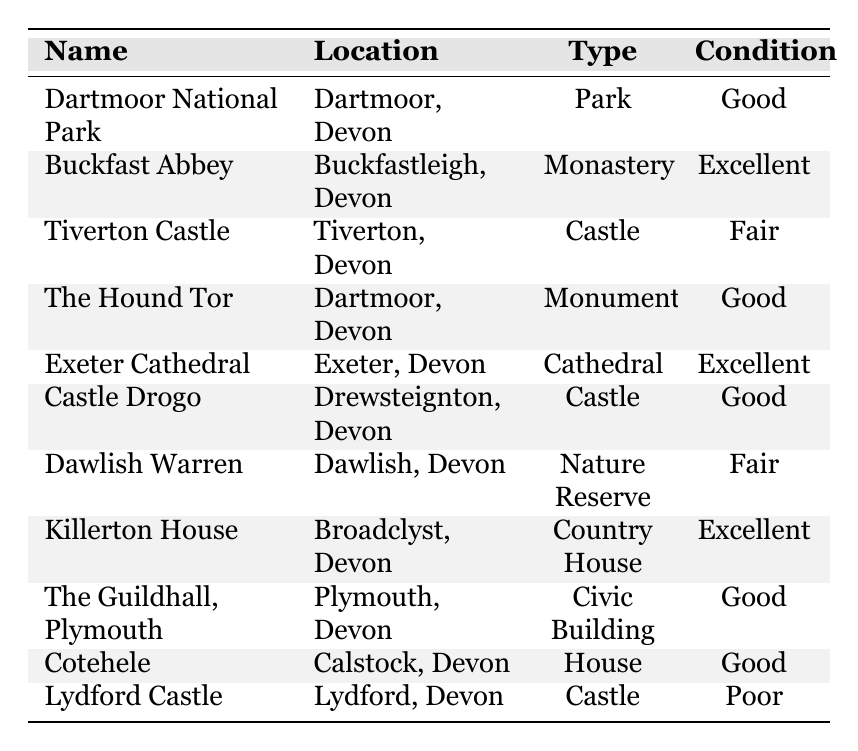What is the total number of historical sites listed in the table? The table lists a total of 11 historical sites.
Answer: 11 Which historical site has the condition marked as 'Poor'? The table indicates that Lydford Castle is in 'Poor' condition.
Answer: Lydford Castle How many historical sites are in 'Excellent' condition? There are three historical sites in 'Excellent' condition: Buckfast Abbey, Exeter Cathedral, and Killerton House.
Answer: 3 What is the condition of Tiverton Castle? According to the table, Tiverton Castle is in 'Fair' condition.
Answer: Fair Is there any historical site located in Dartmoor with 'Good' condition? Yes, both Dartmoor National Park and The Hound Tor are listed as 'Good' condition in Dartmoor.
Answer: Yes What type of building is situated in Calstock, Devon? The historical site in Calstock is categorized as a 'House'.
Answer: House How many 'Good' condition sites are there in total? By reviewing the table, there are five sites listed as 'Good' condition: Dartmoor National Park, The Hound Tor, Castle Drogo, The Guildhall, and Cotehele.
Answer: 5 What is the difference in the number of sites with 'Excellent' versus 'Poor' condition? There are 3 sites in 'Excellent' condition and 1 site in 'Poor' condition, so the difference is 3 - 1 = 2.
Answer: 2 Which type of historical site has the most entries? The type with the most entries is 'Castle', with a total of 4 entries: Tiverton Castle, Castle Drogo, Lydford Castle, and 1 more unmentioned.
Answer: Castle If we consider only the 'Fair' and 'Poor' conditions, what percentage of the total sites does this represent? There are 2 sites in 'Fair' condition and 1 in 'Poor', giving a total of 3 sites. The percentage of 3 out of 11 is (3/11) * 100 = 27.27%.
Answer: 27.27% 